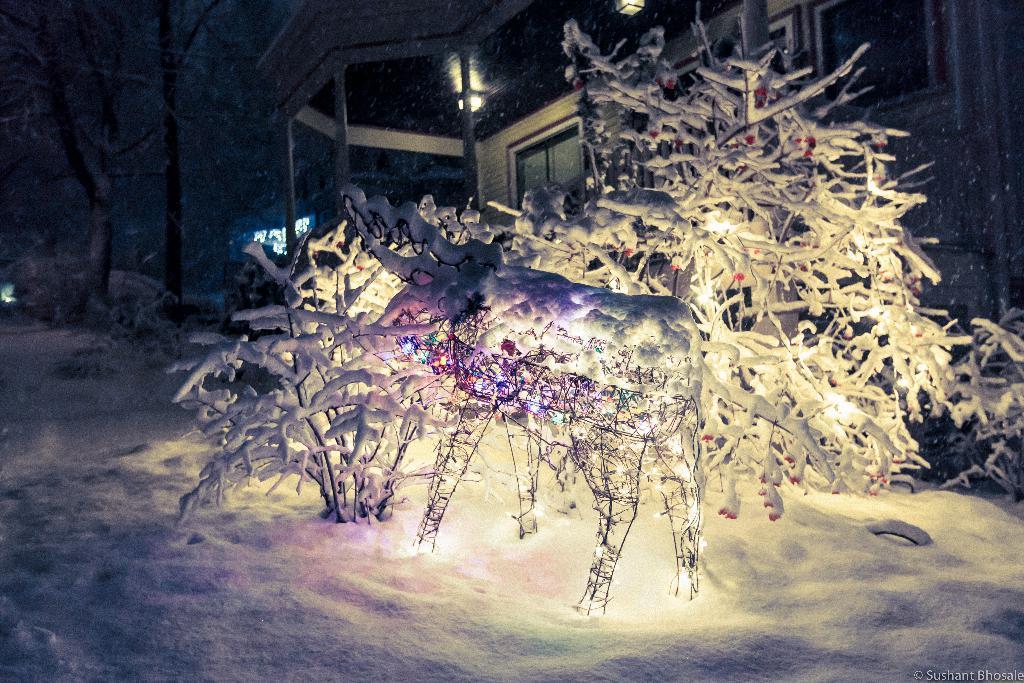Please provide a concise description of this image. In this picture we can see tree and an animal structure where they are on the snow and in the background we can see house with window, light, pillar. 